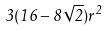<formula> <loc_0><loc_0><loc_500><loc_500>3 ( 1 6 - 8 \sqrt { 2 } ) r ^ { 2 }</formula> 